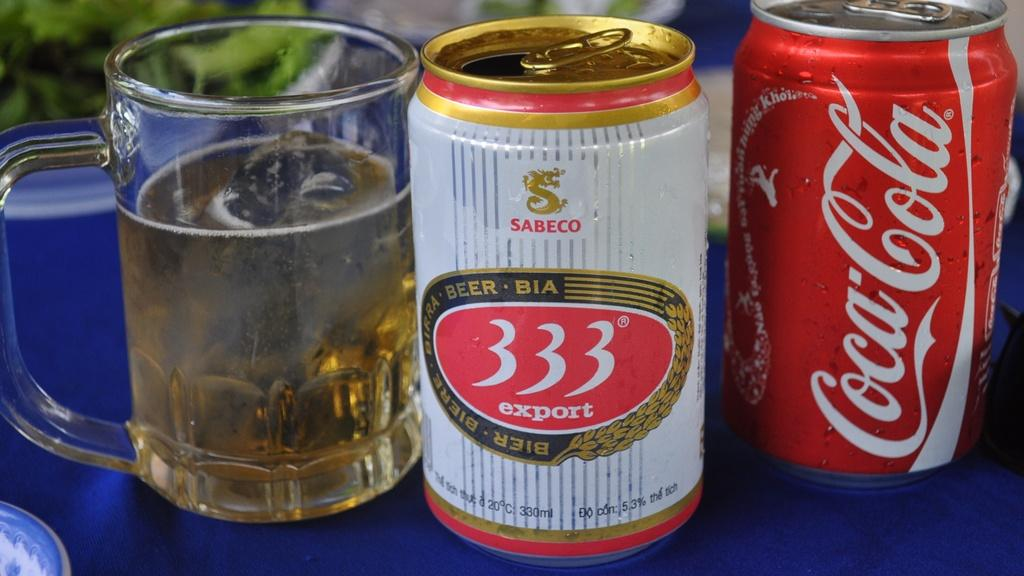<image>
Create a compact narrative representing the image presented. A can of Coca-Cola stands next to a can of 333 Export. 